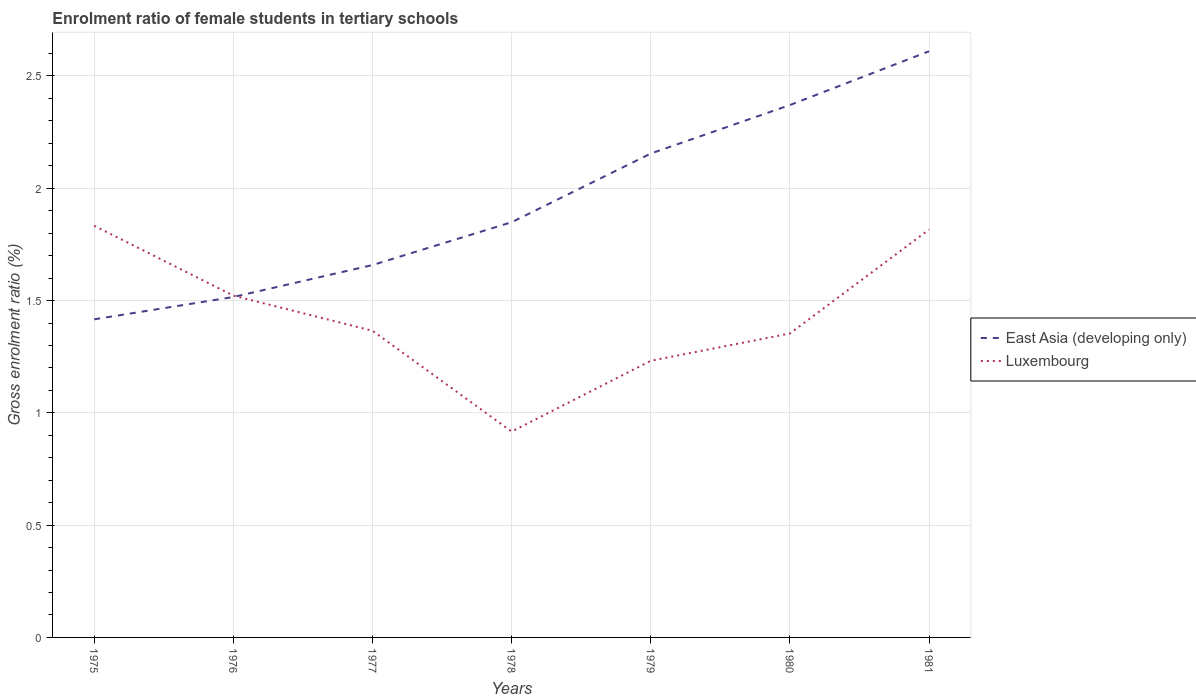How many different coloured lines are there?
Offer a terse response. 2. Across all years, what is the maximum enrolment ratio of female students in tertiary schools in East Asia (developing only)?
Offer a terse response. 1.42. In which year was the enrolment ratio of female students in tertiary schools in Luxembourg maximum?
Provide a short and direct response. 1978. What is the total enrolment ratio of female students in tertiary schools in East Asia (developing only) in the graph?
Give a very brief answer. -1.09. What is the difference between the highest and the second highest enrolment ratio of female students in tertiary schools in Luxembourg?
Your response must be concise. 0.92. What is the difference between the highest and the lowest enrolment ratio of female students in tertiary schools in Luxembourg?
Provide a short and direct response. 3. Is the enrolment ratio of female students in tertiary schools in Luxembourg strictly greater than the enrolment ratio of female students in tertiary schools in East Asia (developing only) over the years?
Offer a terse response. No. How many lines are there?
Your answer should be very brief. 2. How many years are there in the graph?
Offer a very short reply. 7. What is the difference between two consecutive major ticks on the Y-axis?
Make the answer very short. 0.5. Are the values on the major ticks of Y-axis written in scientific E-notation?
Give a very brief answer. No. Does the graph contain grids?
Your response must be concise. Yes. Where does the legend appear in the graph?
Your response must be concise. Center right. How are the legend labels stacked?
Provide a succinct answer. Vertical. What is the title of the graph?
Give a very brief answer. Enrolment ratio of female students in tertiary schools. Does "Panama" appear as one of the legend labels in the graph?
Provide a short and direct response. No. What is the label or title of the Y-axis?
Make the answer very short. Gross enrolment ratio (%). What is the Gross enrolment ratio (%) in East Asia (developing only) in 1975?
Give a very brief answer. 1.42. What is the Gross enrolment ratio (%) in Luxembourg in 1975?
Ensure brevity in your answer.  1.83. What is the Gross enrolment ratio (%) in East Asia (developing only) in 1976?
Provide a succinct answer. 1.52. What is the Gross enrolment ratio (%) of Luxembourg in 1976?
Your response must be concise. 1.52. What is the Gross enrolment ratio (%) in East Asia (developing only) in 1977?
Keep it short and to the point. 1.66. What is the Gross enrolment ratio (%) of Luxembourg in 1977?
Your response must be concise. 1.37. What is the Gross enrolment ratio (%) in East Asia (developing only) in 1978?
Offer a very short reply. 1.85. What is the Gross enrolment ratio (%) of Luxembourg in 1978?
Give a very brief answer. 0.92. What is the Gross enrolment ratio (%) in East Asia (developing only) in 1979?
Offer a terse response. 2.15. What is the Gross enrolment ratio (%) of Luxembourg in 1979?
Provide a short and direct response. 1.23. What is the Gross enrolment ratio (%) of East Asia (developing only) in 1980?
Offer a terse response. 2.37. What is the Gross enrolment ratio (%) of Luxembourg in 1980?
Ensure brevity in your answer.  1.35. What is the Gross enrolment ratio (%) in East Asia (developing only) in 1981?
Give a very brief answer. 2.61. What is the Gross enrolment ratio (%) of Luxembourg in 1981?
Give a very brief answer. 1.82. Across all years, what is the maximum Gross enrolment ratio (%) in East Asia (developing only)?
Your answer should be compact. 2.61. Across all years, what is the maximum Gross enrolment ratio (%) of Luxembourg?
Provide a short and direct response. 1.83. Across all years, what is the minimum Gross enrolment ratio (%) of East Asia (developing only)?
Give a very brief answer. 1.42. Across all years, what is the minimum Gross enrolment ratio (%) of Luxembourg?
Your answer should be very brief. 0.92. What is the total Gross enrolment ratio (%) in East Asia (developing only) in the graph?
Your answer should be very brief. 13.57. What is the total Gross enrolment ratio (%) in Luxembourg in the graph?
Offer a very short reply. 10.04. What is the difference between the Gross enrolment ratio (%) of East Asia (developing only) in 1975 and that in 1976?
Give a very brief answer. -0.1. What is the difference between the Gross enrolment ratio (%) in Luxembourg in 1975 and that in 1976?
Offer a very short reply. 0.31. What is the difference between the Gross enrolment ratio (%) in East Asia (developing only) in 1975 and that in 1977?
Ensure brevity in your answer.  -0.24. What is the difference between the Gross enrolment ratio (%) of Luxembourg in 1975 and that in 1977?
Keep it short and to the point. 0.47. What is the difference between the Gross enrolment ratio (%) of East Asia (developing only) in 1975 and that in 1978?
Offer a very short reply. -0.43. What is the difference between the Gross enrolment ratio (%) of Luxembourg in 1975 and that in 1978?
Keep it short and to the point. 0.92. What is the difference between the Gross enrolment ratio (%) of East Asia (developing only) in 1975 and that in 1979?
Provide a short and direct response. -0.74. What is the difference between the Gross enrolment ratio (%) of Luxembourg in 1975 and that in 1979?
Provide a succinct answer. 0.6. What is the difference between the Gross enrolment ratio (%) of East Asia (developing only) in 1975 and that in 1980?
Offer a very short reply. -0.95. What is the difference between the Gross enrolment ratio (%) in Luxembourg in 1975 and that in 1980?
Offer a terse response. 0.48. What is the difference between the Gross enrolment ratio (%) in East Asia (developing only) in 1975 and that in 1981?
Give a very brief answer. -1.19. What is the difference between the Gross enrolment ratio (%) in Luxembourg in 1975 and that in 1981?
Ensure brevity in your answer.  0.02. What is the difference between the Gross enrolment ratio (%) of East Asia (developing only) in 1976 and that in 1977?
Ensure brevity in your answer.  -0.14. What is the difference between the Gross enrolment ratio (%) in Luxembourg in 1976 and that in 1977?
Your answer should be compact. 0.16. What is the difference between the Gross enrolment ratio (%) of East Asia (developing only) in 1976 and that in 1978?
Offer a very short reply. -0.33. What is the difference between the Gross enrolment ratio (%) of Luxembourg in 1976 and that in 1978?
Provide a short and direct response. 0.61. What is the difference between the Gross enrolment ratio (%) of East Asia (developing only) in 1976 and that in 1979?
Ensure brevity in your answer.  -0.64. What is the difference between the Gross enrolment ratio (%) in Luxembourg in 1976 and that in 1979?
Give a very brief answer. 0.29. What is the difference between the Gross enrolment ratio (%) in East Asia (developing only) in 1976 and that in 1980?
Give a very brief answer. -0.85. What is the difference between the Gross enrolment ratio (%) of Luxembourg in 1976 and that in 1980?
Keep it short and to the point. 0.17. What is the difference between the Gross enrolment ratio (%) in East Asia (developing only) in 1976 and that in 1981?
Ensure brevity in your answer.  -1.09. What is the difference between the Gross enrolment ratio (%) in Luxembourg in 1976 and that in 1981?
Your answer should be very brief. -0.29. What is the difference between the Gross enrolment ratio (%) of East Asia (developing only) in 1977 and that in 1978?
Your answer should be compact. -0.19. What is the difference between the Gross enrolment ratio (%) of Luxembourg in 1977 and that in 1978?
Offer a very short reply. 0.45. What is the difference between the Gross enrolment ratio (%) in East Asia (developing only) in 1977 and that in 1979?
Your answer should be very brief. -0.5. What is the difference between the Gross enrolment ratio (%) of Luxembourg in 1977 and that in 1979?
Keep it short and to the point. 0.13. What is the difference between the Gross enrolment ratio (%) of East Asia (developing only) in 1977 and that in 1980?
Keep it short and to the point. -0.71. What is the difference between the Gross enrolment ratio (%) in Luxembourg in 1977 and that in 1980?
Keep it short and to the point. 0.01. What is the difference between the Gross enrolment ratio (%) of East Asia (developing only) in 1977 and that in 1981?
Your answer should be very brief. -0.95. What is the difference between the Gross enrolment ratio (%) of Luxembourg in 1977 and that in 1981?
Your response must be concise. -0.45. What is the difference between the Gross enrolment ratio (%) of East Asia (developing only) in 1978 and that in 1979?
Give a very brief answer. -0.31. What is the difference between the Gross enrolment ratio (%) in Luxembourg in 1978 and that in 1979?
Keep it short and to the point. -0.32. What is the difference between the Gross enrolment ratio (%) in East Asia (developing only) in 1978 and that in 1980?
Offer a terse response. -0.52. What is the difference between the Gross enrolment ratio (%) in Luxembourg in 1978 and that in 1980?
Provide a short and direct response. -0.44. What is the difference between the Gross enrolment ratio (%) in East Asia (developing only) in 1978 and that in 1981?
Ensure brevity in your answer.  -0.76. What is the difference between the Gross enrolment ratio (%) in Luxembourg in 1978 and that in 1981?
Make the answer very short. -0.9. What is the difference between the Gross enrolment ratio (%) in East Asia (developing only) in 1979 and that in 1980?
Ensure brevity in your answer.  -0.22. What is the difference between the Gross enrolment ratio (%) of Luxembourg in 1979 and that in 1980?
Keep it short and to the point. -0.12. What is the difference between the Gross enrolment ratio (%) in East Asia (developing only) in 1979 and that in 1981?
Keep it short and to the point. -0.46. What is the difference between the Gross enrolment ratio (%) in Luxembourg in 1979 and that in 1981?
Offer a very short reply. -0.58. What is the difference between the Gross enrolment ratio (%) of East Asia (developing only) in 1980 and that in 1981?
Your response must be concise. -0.24. What is the difference between the Gross enrolment ratio (%) in Luxembourg in 1980 and that in 1981?
Provide a succinct answer. -0.46. What is the difference between the Gross enrolment ratio (%) in East Asia (developing only) in 1975 and the Gross enrolment ratio (%) in Luxembourg in 1976?
Give a very brief answer. -0.11. What is the difference between the Gross enrolment ratio (%) of East Asia (developing only) in 1975 and the Gross enrolment ratio (%) of Luxembourg in 1977?
Your response must be concise. 0.05. What is the difference between the Gross enrolment ratio (%) in East Asia (developing only) in 1975 and the Gross enrolment ratio (%) in Luxembourg in 1978?
Your answer should be compact. 0.5. What is the difference between the Gross enrolment ratio (%) of East Asia (developing only) in 1975 and the Gross enrolment ratio (%) of Luxembourg in 1979?
Your answer should be very brief. 0.18. What is the difference between the Gross enrolment ratio (%) in East Asia (developing only) in 1975 and the Gross enrolment ratio (%) in Luxembourg in 1980?
Give a very brief answer. 0.06. What is the difference between the Gross enrolment ratio (%) in East Asia (developing only) in 1975 and the Gross enrolment ratio (%) in Luxembourg in 1981?
Your response must be concise. -0.4. What is the difference between the Gross enrolment ratio (%) of East Asia (developing only) in 1976 and the Gross enrolment ratio (%) of Luxembourg in 1977?
Keep it short and to the point. 0.15. What is the difference between the Gross enrolment ratio (%) of East Asia (developing only) in 1976 and the Gross enrolment ratio (%) of Luxembourg in 1978?
Give a very brief answer. 0.6. What is the difference between the Gross enrolment ratio (%) of East Asia (developing only) in 1976 and the Gross enrolment ratio (%) of Luxembourg in 1979?
Keep it short and to the point. 0.28. What is the difference between the Gross enrolment ratio (%) of East Asia (developing only) in 1976 and the Gross enrolment ratio (%) of Luxembourg in 1980?
Provide a succinct answer. 0.16. What is the difference between the Gross enrolment ratio (%) of East Asia (developing only) in 1976 and the Gross enrolment ratio (%) of Luxembourg in 1981?
Provide a short and direct response. -0.3. What is the difference between the Gross enrolment ratio (%) of East Asia (developing only) in 1977 and the Gross enrolment ratio (%) of Luxembourg in 1978?
Your answer should be compact. 0.74. What is the difference between the Gross enrolment ratio (%) of East Asia (developing only) in 1977 and the Gross enrolment ratio (%) of Luxembourg in 1979?
Offer a terse response. 0.43. What is the difference between the Gross enrolment ratio (%) in East Asia (developing only) in 1977 and the Gross enrolment ratio (%) in Luxembourg in 1980?
Keep it short and to the point. 0.3. What is the difference between the Gross enrolment ratio (%) in East Asia (developing only) in 1977 and the Gross enrolment ratio (%) in Luxembourg in 1981?
Your answer should be very brief. -0.16. What is the difference between the Gross enrolment ratio (%) in East Asia (developing only) in 1978 and the Gross enrolment ratio (%) in Luxembourg in 1979?
Your answer should be very brief. 0.62. What is the difference between the Gross enrolment ratio (%) in East Asia (developing only) in 1978 and the Gross enrolment ratio (%) in Luxembourg in 1980?
Offer a terse response. 0.5. What is the difference between the Gross enrolment ratio (%) in East Asia (developing only) in 1978 and the Gross enrolment ratio (%) in Luxembourg in 1981?
Provide a succinct answer. 0.03. What is the difference between the Gross enrolment ratio (%) of East Asia (developing only) in 1979 and the Gross enrolment ratio (%) of Luxembourg in 1980?
Give a very brief answer. 0.8. What is the difference between the Gross enrolment ratio (%) in East Asia (developing only) in 1979 and the Gross enrolment ratio (%) in Luxembourg in 1981?
Offer a terse response. 0.34. What is the difference between the Gross enrolment ratio (%) of East Asia (developing only) in 1980 and the Gross enrolment ratio (%) of Luxembourg in 1981?
Provide a short and direct response. 0.55. What is the average Gross enrolment ratio (%) in East Asia (developing only) per year?
Your answer should be very brief. 1.94. What is the average Gross enrolment ratio (%) of Luxembourg per year?
Make the answer very short. 1.43. In the year 1975, what is the difference between the Gross enrolment ratio (%) of East Asia (developing only) and Gross enrolment ratio (%) of Luxembourg?
Keep it short and to the point. -0.42. In the year 1976, what is the difference between the Gross enrolment ratio (%) of East Asia (developing only) and Gross enrolment ratio (%) of Luxembourg?
Provide a succinct answer. -0.01. In the year 1977, what is the difference between the Gross enrolment ratio (%) in East Asia (developing only) and Gross enrolment ratio (%) in Luxembourg?
Ensure brevity in your answer.  0.29. In the year 1978, what is the difference between the Gross enrolment ratio (%) of East Asia (developing only) and Gross enrolment ratio (%) of Luxembourg?
Keep it short and to the point. 0.93. In the year 1979, what is the difference between the Gross enrolment ratio (%) of East Asia (developing only) and Gross enrolment ratio (%) of Luxembourg?
Ensure brevity in your answer.  0.92. In the year 1980, what is the difference between the Gross enrolment ratio (%) of East Asia (developing only) and Gross enrolment ratio (%) of Luxembourg?
Provide a succinct answer. 1.02. In the year 1981, what is the difference between the Gross enrolment ratio (%) in East Asia (developing only) and Gross enrolment ratio (%) in Luxembourg?
Give a very brief answer. 0.79. What is the ratio of the Gross enrolment ratio (%) in East Asia (developing only) in 1975 to that in 1976?
Your response must be concise. 0.93. What is the ratio of the Gross enrolment ratio (%) in Luxembourg in 1975 to that in 1976?
Your answer should be compact. 1.2. What is the ratio of the Gross enrolment ratio (%) of East Asia (developing only) in 1975 to that in 1977?
Your answer should be compact. 0.85. What is the ratio of the Gross enrolment ratio (%) of Luxembourg in 1975 to that in 1977?
Keep it short and to the point. 1.34. What is the ratio of the Gross enrolment ratio (%) in East Asia (developing only) in 1975 to that in 1978?
Your answer should be very brief. 0.77. What is the ratio of the Gross enrolment ratio (%) of Luxembourg in 1975 to that in 1978?
Offer a very short reply. 2. What is the ratio of the Gross enrolment ratio (%) of East Asia (developing only) in 1975 to that in 1979?
Provide a succinct answer. 0.66. What is the ratio of the Gross enrolment ratio (%) in Luxembourg in 1975 to that in 1979?
Give a very brief answer. 1.49. What is the ratio of the Gross enrolment ratio (%) in East Asia (developing only) in 1975 to that in 1980?
Ensure brevity in your answer.  0.6. What is the ratio of the Gross enrolment ratio (%) in Luxembourg in 1975 to that in 1980?
Your answer should be compact. 1.35. What is the ratio of the Gross enrolment ratio (%) in East Asia (developing only) in 1975 to that in 1981?
Keep it short and to the point. 0.54. What is the ratio of the Gross enrolment ratio (%) of Luxembourg in 1975 to that in 1981?
Your answer should be very brief. 1.01. What is the ratio of the Gross enrolment ratio (%) of East Asia (developing only) in 1976 to that in 1977?
Your answer should be very brief. 0.91. What is the ratio of the Gross enrolment ratio (%) in Luxembourg in 1976 to that in 1977?
Give a very brief answer. 1.11. What is the ratio of the Gross enrolment ratio (%) of East Asia (developing only) in 1976 to that in 1978?
Make the answer very short. 0.82. What is the ratio of the Gross enrolment ratio (%) in Luxembourg in 1976 to that in 1978?
Ensure brevity in your answer.  1.66. What is the ratio of the Gross enrolment ratio (%) in East Asia (developing only) in 1976 to that in 1979?
Your response must be concise. 0.7. What is the ratio of the Gross enrolment ratio (%) of Luxembourg in 1976 to that in 1979?
Make the answer very short. 1.24. What is the ratio of the Gross enrolment ratio (%) of East Asia (developing only) in 1976 to that in 1980?
Make the answer very short. 0.64. What is the ratio of the Gross enrolment ratio (%) in Luxembourg in 1976 to that in 1980?
Provide a short and direct response. 1.12. What is the ratio of the Gross enrolment ratio (%) of East Asia (developing only) in 1976 to that in 1981?
Keep it short and to the point. 0.58. What is the ratio of the Gross enrolment ratio (%) of Luxembourg in 1976 to that in 1981?
Offer a very short reply. 0.84. What is the ratio of the Gross enrolment ratio (%) of East Asia (developing only) in 1977 to that in 1978?
Offer a very short reply. 0.9. What is the ratio of the Gross enrolment ratio (%) of Luxembourg in 1977 to that in 1978?
Offer a very short reply. 1.49. What is the ratio of the Gross enrolment ratio (%) of East Asia (developing only) in 1977 to that in 1979?
Offer a terse response. 0.77. What is the ratio of the Gross enrolment ratio (%) in Luxembourg in 1977 to that in 1979?
Make the answer very short. 1.11. What is the ratio of the Gross enrolment ratio (%) in East Asia (developing only) in 1977 to that in 1980?
Give a very brief answer. 0.7. What is the ratio of the Gross enrolment ratio (%) in Luxembourg in 1977 to that in 1980?
Make the answer very short. 1.01. What is the ratio of the Gross enrolment ratio (%) in East Asia (developing only) in 1977 to that in 1981?
Offer a very short reply. 0.64. What is the ratio of the Gross enrolment ratio (%) of Luxembourg in 1977 to that in 1981?
Provide a succinct answer. 0.75. What is the ratio of the Gross enrolment ratio (%) of East Asia (developing only) in 1978 to that in 1979?
Your answer should be very brief. 0.86. What is the ratio of the Gross enrolment ratio (%) in Luxembourg in 1978 to that in 1979?
Give a very brief answer. 0.74. What is the ratio of the Gross enrolment ratio (%) in East Asia (developing only) in 1978 to that in 1980?
Give a very brief answer. 0.78. What is the ratio of the Gross enrolment ratio (%) in Luxembourg in 1978 to that in 1980?
Provide a short and direct response. 0.68. What is the ratio of the Gross enrolment ratio (%) in East Asia (developing only) in 1978 to that in 1981?
Your answer should be very brief. 0.71. What is the ratio of the Gross enrolment ratio (%) of Luxembourg in 1978 to that in 1981?
Your answer should be very brief. 0.5. What is the ratio of the Gross enrolment ratio (%) in East Asia (developing only) in 1979 to that in 1980?
Make the answer very short. 0.91. What is the ratio of the Gross enrolment ratio (%) in Luxembourg in 1979 to that in 1980?
Offer a very short reply. 0.91. What is the ratio of the Gross enrolment ratio (%) of East Asia (developing only) in 1979 to that in 1981?
Offer a terse response. 0.83. What is the ratio of the Gross enrolment ratio (%) in Luxembourg in 1979 to that in 1981?
Your answer should be very brief. 0.68. What is the ratio of the Gross enrolment ratio (%) in East Asia (developing only) in 1980 to that in 1981?
Ensure brevity in your answer.  0.91. What is the ratio of the Gross enrolment ratio (%) in Luxembourg in 1980 to that in 1981?
Offer a terse response. 0.75. What is the difference between the highest and the second highest Gross enrolment ratio (%) of East Asia (developing only)?
Give a very brief answer. 0.24. What is the difference between the highest and the second highest Gross enrolment ratio (%) in Luxembourg?
Give a very brief answer. 0.02. What is the difference between the highest and the lowest Gross enrolment ratio (%) of East Asia (developing only)?
Offer a terse response. 1.19. What is the difference between the highest and the lowest Gross enrolment ratio (%) of Luxembourg?
Your response must be concise. 0.92. 